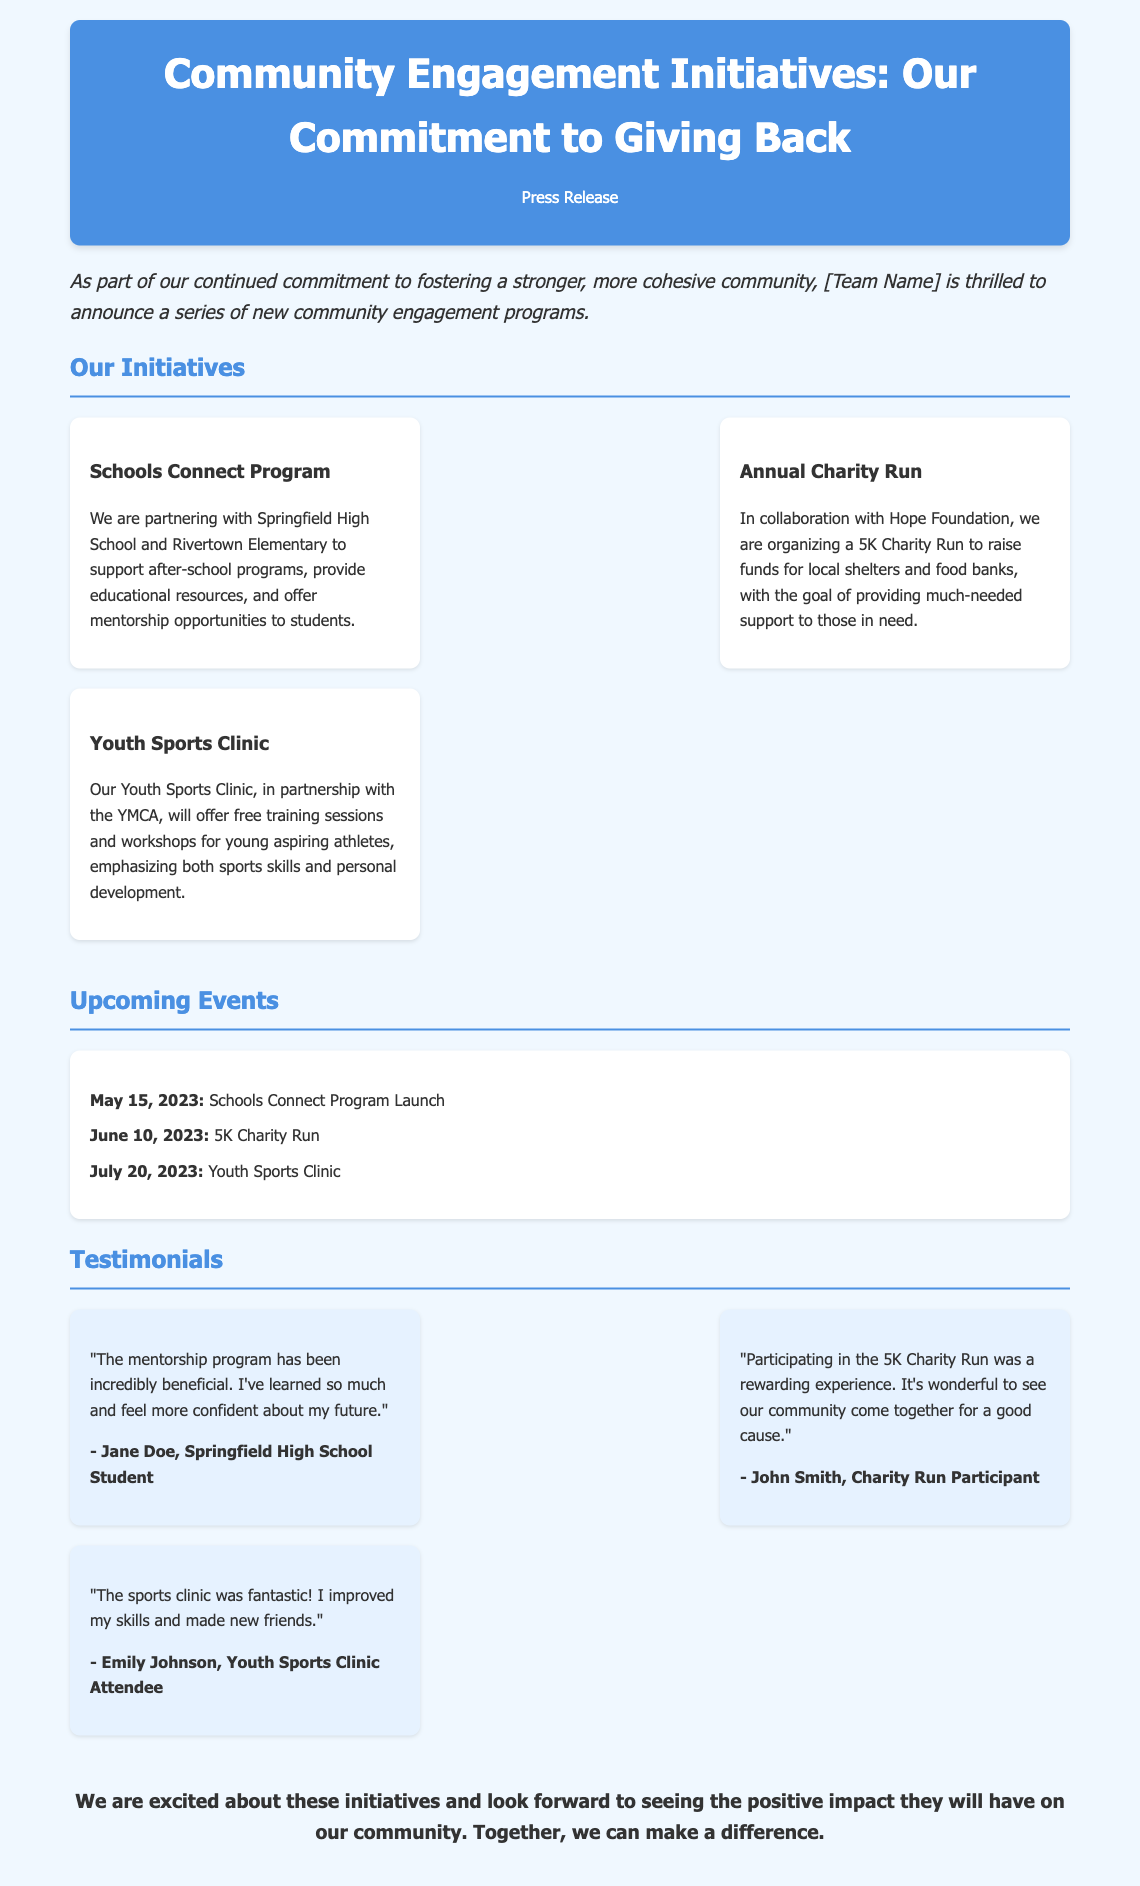what is the title of the press release? The title of the press release is prominently displayed at the top of the document.
Answer: Community Engagement Initiatives: Our Commitment to Giving Back what are the names of the schools involved in the Schools Connect Program? The document mentions two specific schools participating in the program.
Answer: Springfield High School and Rivertown Elementary when is the Youth Sports Clinic scheduled? The event calendar lists the date specifically for the Youth Sports Clinic.
Answer: July 20, 2023 who organized the 5K Charity Run? The document specifies the organization collaborating on the Charity Run.
Answer: Hope Foundation which program focuses on mentorship opportunities? The document indicates a specific program dedicated to mentorship for students.
Answer: Schools Connect Program how many testimonials are included in the document? The testimonials section lists three participants' feedback.
Answer: Three what is the main goal of the Annual Charity Run? The document describes the purpose of this charity event.
Answer: To raise funds for local shelters and food banks what is the overall goal of the community engagement initiatives? The introduction summarizes the main aim of the initiatives in a single statement.
Answer: To foster a stronger, more cohesive community 